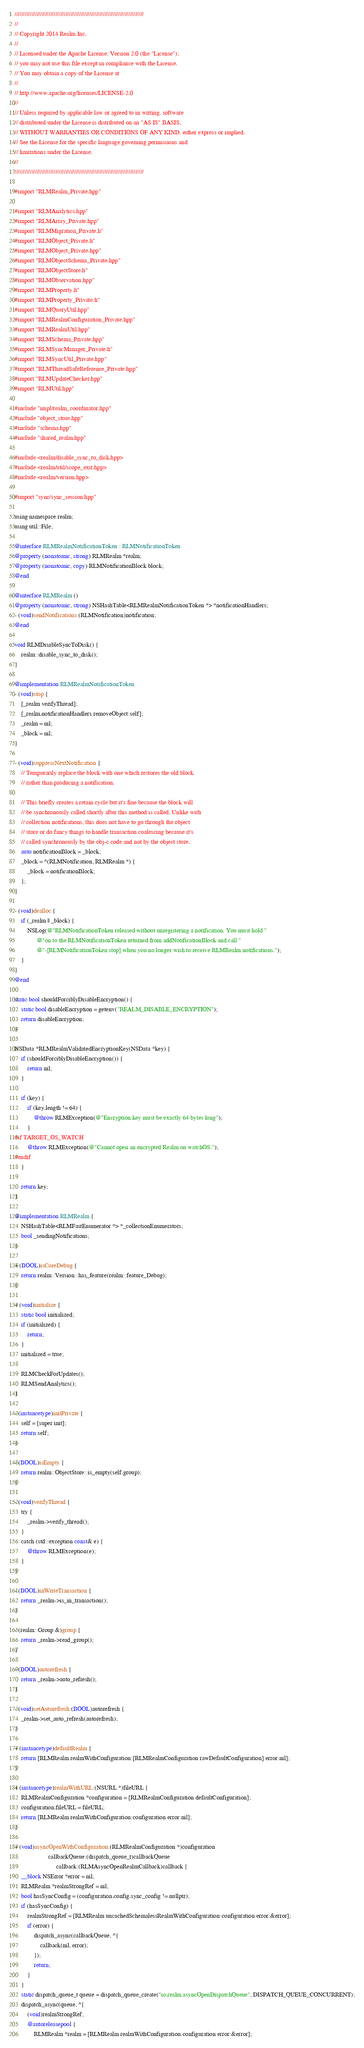Convert code to text. <code><loc_0><loc_0><loc_500><loc_500><_ObjectiveC_>////////////////////////////////////////////////////////////////////////////
//
// Copyright 2014 Realm Inc.
//
// Licensed under the Apache License, Version 2.0 (the "License");
// you may not use this file except in compliance with the License.
// You may obtain a copy of the License at
//
// http://www.apache.org/licenses/LICENSE-2.0
//
// Unless required by applicable law or agreed to in writing, software
// distributed under the License is distributed on an "AS IS" BASIS,
// WITHOUT WARRANTIES OR CONDITIONS OF ANY KIND, either express or implied.
// See the License for the specific language governing permissions and
// limitations under the License.
//
////////////////////////////////////////////////////////////////////////////

#import "RLMRealm_Private.hpp"

#import "RLMAnalytics.hpp"
#import "RLMArray_Private.hpp"
#import "RLMMigration_Private.h"
#import "RLMObject_Private.h"
#import "RLMObject_Private.hpp"
#import "RLMObjectSchema_Private.hpp"
#import "RLMObjectStore.h"
#import "RLMObservation.hpp"
#import "RLMProperty.h"
#import "RLMProperty_Private.h"
#import "RLMQueryUtil.hpp"
#import "RLMRealmConfiguration_Private.hpp"
#import "RLMRealmUtil.hpp"
#import "RLMSchema_Private.hpp"
#import "RLMSyncManager_Private.h"
#import "RLMSyncUtil_Private.hpp"
#import "RLMThreadSafeReference_Private.hpp"
#import "RLMUpdateChecker.hpp"
#import "RLMUtil.hpp"

#include "impl/realm_coordinator.hpp"
#include "object_store.hpp"
#include "schema.hpp"
#include "shared_realm.hpp"

#include <realm/disable_sync_to_disk.hpp>
#include <realm/util/scope_exit.hpp>
#include <realm/version.hpp>

#import "sync/sync_session.hpp"

using namespace realm;
using util::File;

@interface RLMRealmNotificationToken : RLMNotificationToken
@property (nonatomic, strong) RLMRealm *realm;
@property (nonatomic, copy) RLMNotificationBlock block;
@end

@interface RLMRealm ()
@property (nonatomic, strong) NSHashTable<RLMRealmNotificationToken *> *notificationHandlers;
- (void)sendNotifications:(RLMNotification)notification;
@end

void RLMDisableSyncToDisk() {
    realm::disable_sync_to_disk();
}

@implementation RLMRealmNotificationToken
- (void)stop {
    [_realm verifyThread];
    [_realm.notificationHandlers removeObject:self];
    _realm = nil;
    _block = nil;
}

- (void)suppressNextNotification {
    // Temporarily replace the block with one which restores the old block
    // rather than producing a notification.

    // This briefly creates a retain cycle but it's fine because the block will
    // be synchronously called shortly after this method is called. Unlike with
    // collection notifications, this does not have to go through the object
    // store or do fancy things to handle transaction coalescing because it's
    // called synchronously by the obj-c code and not by the object store.
    auto notificationBlock = _block;
    _block = ^(RLMNotification, RLMRealm *) {
        _block = notificationBlock;
    };
}

- (void)dealloc {
    if (_realm || _block) {
        NSLog(@"RLMNotificationToken released without unregistering a notification. You must hold "
              @"on to the RLMNotificationToken returned from addNotificationBlock and call "
              @"-[RLMNotificationToken stop] when you no longer wish to receive RLMRealm notifications.");
    }
}
@end

static bool shouldForciblyDisableEncryption() {
    static bool disableEncryption = getenv("REALM_DISABLE_ENCRYPTION");
    return disableEncryption;
}

NSData *RLMRealmValidatedEncryptionKey(NSData *key) {
    if (shouldForciblyDisableEncryption()) {
        return nil;
    }

    if (key) {
        if (key.length != 64) {
            @throw RLMException(@"Encryption key must be exactly 64 bytes long");
        }
#if TARGET_OS_WATCH
        @throw RLMException(@"Cannot open an encrypted Realm on watchOS.");
#endif
    }

    return key;
}

@implementation RLMRealm {
    NSHashTable<RLMFastEnumerator *> *_collectionEnumerators;
    bool _sendingNotifications;
}

+ (BOOL)isCoreDebug {
    return realm::Version::has_feature(realm::feature_Debug);
}

+ (void)initialize {
    static bool initialized;
    if (initialized) {
        return;
    }
    initialized = true;

    RLMCheckForUpdates();
    RLMSendAnalytics();
}

- (instancetype)initPrivate {
    self = [super init];
    return self;
}

- (BOOL)isEmpty {
    return realm::ObjectStore::is_empty(self.group);
}

- (void)verifyThread {
    try {
        _realm->verify_thread();
    }
    catch (std::exception const& e) {
        @throw RLMException(e);
    }
}

- (BOOL)inWriteTransaction {
    return _realm->is_in_transaction();
}

- (realm::Group &)group {
    return _realm->read_group();
}

- (BOOL)autorefresh {
    return _realm->auto_refresh();
}

- (void)setAutorefresh:(BOOL)autorefresh {
    _realm->set_auto_refresh(autorefresh);
}

+ (instancetype)defaultRealm {
    return [RLMRealm realmWithConfiguration:[RLMRealmConfiguration rawDefaultConfiguration] error:nil];
}

+ (instancetype)realmWithURL:(NSURL *)fileURL {
    RLMRealmConfiguration *configuration = [RLMRealmConfiguration defaultConfiguration];
    configuration.fileURL = fileURL;
    return [RLMRealm realmWithConfiguration:configuration error:nil];
}

+ (void)asyncOpenWithConfiguration:(RLMRealmConfiguration *)configuration
                     callbackQueue:(dispatch_queue_t)callbackQueue
                          callback:(RLMAsyncOpenRealmCallback)callback {
    __block NSError *error = nil;
    RLMRealm *realmStrongRef = nil;
    bool hasSyncConfig = (configuration.config.sync_config != nullptr);
    if (hasSyncConfig) {
        realmStrongRef = [RLMRealm uncachedSchemalessRealmWithConfiguration:configuration error:&error];
        if (error) {
            dispatch_async(callbackQueue, ^{
                callback(nil, error);
            });
            return;
        }
    }
    static dispatch_queue_t queue = dispatch_queue_create("io.realm.asyncOpenDispatchQueue", DISPATCH_QUEUE_CONCURRENT);
    dispatch_async(queue, ^{
        (void)realmStrongRef;
        @autoreleasepool {
            RLMRealm *realm = [RLMRealm realmWithConfiguration:configuration error:&error];</code> 